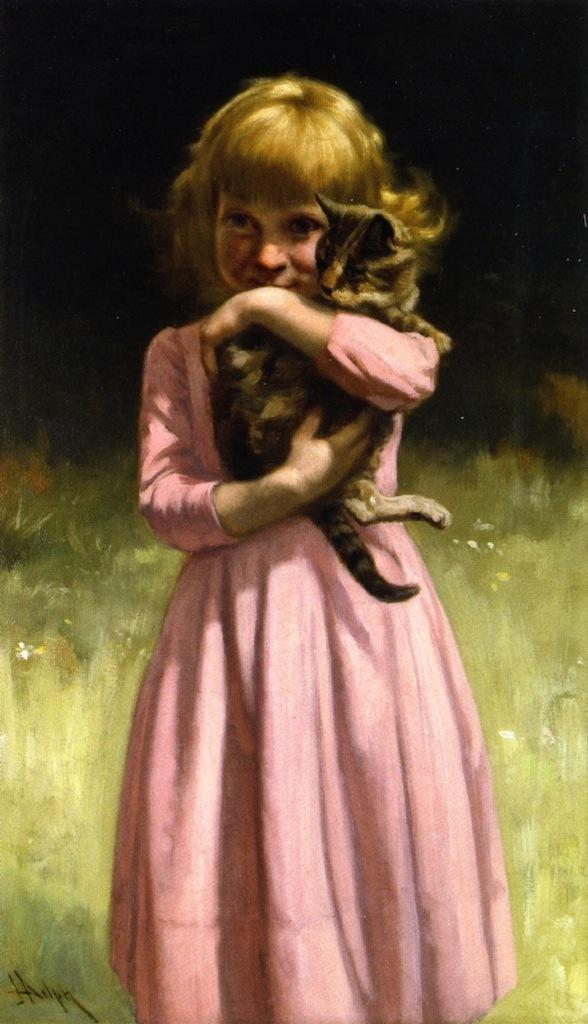Who is present in the image? There is a girl in the image. What is the girl holding in the image? The girl is holding a cat. What type of artwork is the image? The image is painted. What type of silk fabric is draped over the hall in the image? There is no silk fabric or hall present in the image; it features a girl holding a cat in a painted scene. 